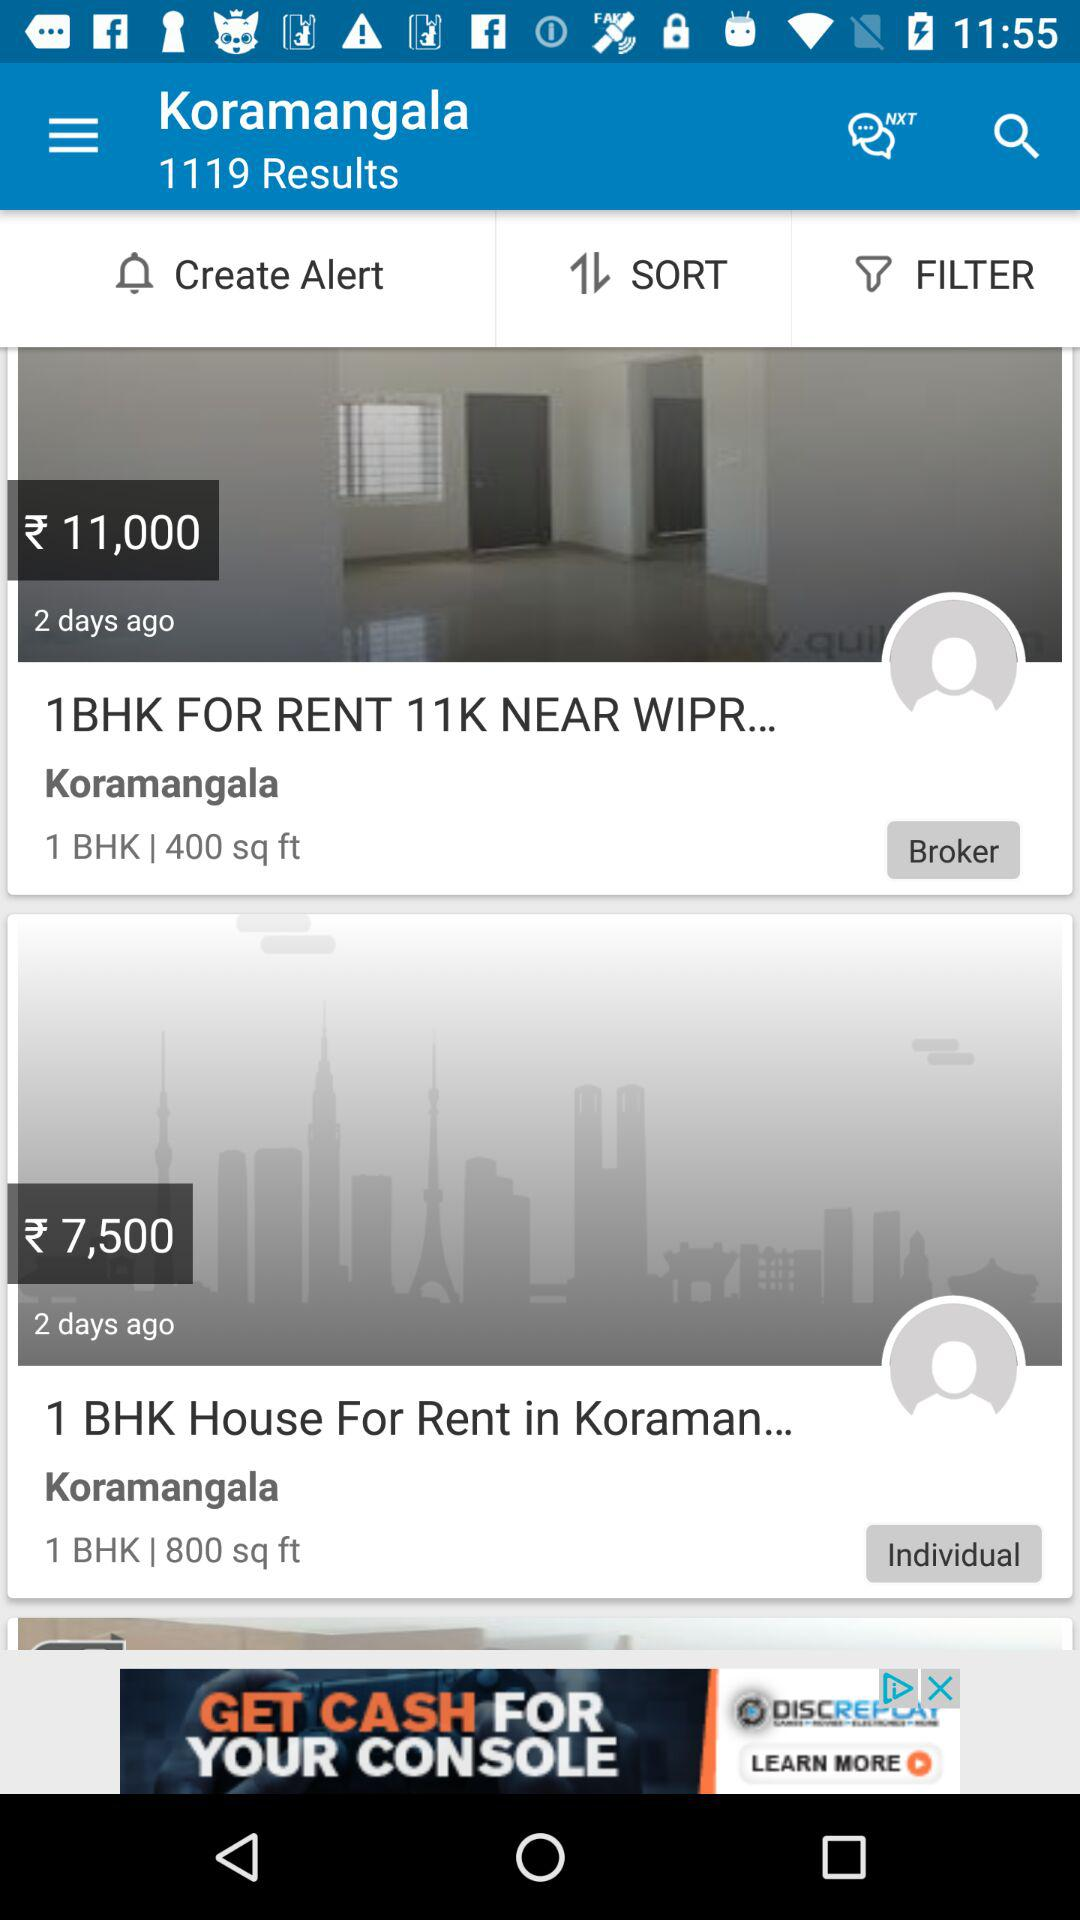What is the rent for the rooms? The rent for the rooms is ₹11,000 and ₹7,500. 